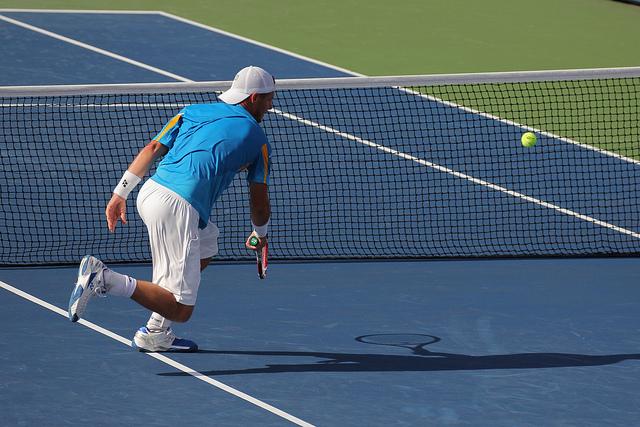What color is the court?
Quick response, please. Blue. What color is the ball?
Quick response, please. Yellow. What sport is this?
Be succinct. Tennis. 